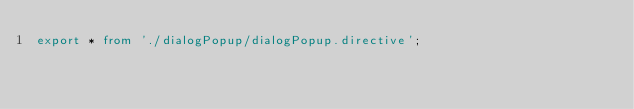Convert code to text. <code><loc_0><loc_0><loc_500><loc_500><_TypeScript_>export * from './dialogPopup/dialogPopup.directive';</code> 